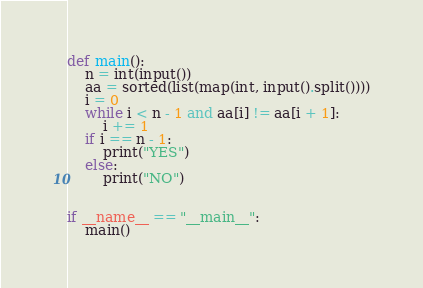<code> <loc_0><loc_0><loc_500><loc_500><_Python_>def main():
    n = int(input())
    aa = sorted(list(map(int, input().split())))
    i = 0
    while i < n - 1 and aa[i] != aa[i + 1]:
        i += 1
    if i == n - 1:
        print("YES")
    else:
        print("NO")


if __name__ == "__main__":
    main()</code> 